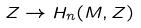Convert formula to latex. <formula><loc_0><loc_0><loc_500><loc_500>Z \rightarrow H _ { n } ( M , Z )</formula> 